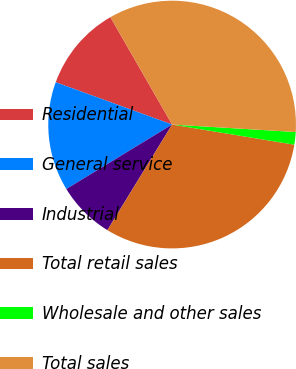<chart> <loc_0><loc_0><loc_500><loc_500><pie_chart><fcel>Residential<fcel>General service<fcel>Industrial<fcel>Total retail sales<fcel>Wholesale and other sales<fcel>Total sales<nl><fcel>11.15%<fcel>14.26%<fcel>7.54%<fcel>31.15%<fcel>1.64%<fcel>34.26%<nl></chart> 